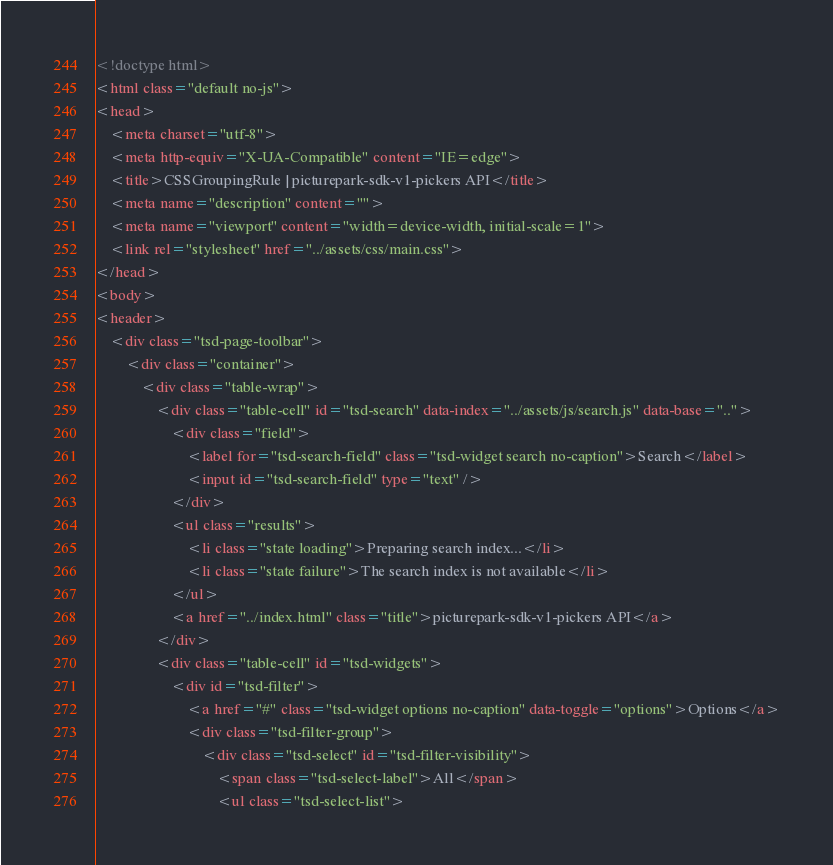<code> <loc_0><loc_0><loc_500><loc_500><_HTML_><!doctype html>
<html class="default no-js">
<head>
	<meta charset="utf-8">
	<meta http-equiv="X-UA-Compatible" content="IE=edge">
	<title>CSSGroupingRule | picturepark-sdk-v1-pickers API</title>
	<meta name="description" content="">
	<meta name="viewport" content="width=device-width, initial-scale=1">
	<link rel="stylesheet" href="../assets/css/main.css">
</head>
<body>
<header>
	<div class="tsd-page-toolbar">
		<div class="container">
			<div class="table-wrap">
				<div class="table-cell" id="tsd-search" data-index="../assets/js/search.js" data-base="..">
					<div class="field">
						<label for="tsd-search-field" class="tsd-widget search no-caption">Search</label>
						<input id="tsd-search-field" type="text" />
					</div>
					<ul class="results">
						<li class="state loading">Preparing search index...</li>
						<li class="state failure">The search index is not available</li>
					</ul>
					<a href="../index.html" class="title">picturepark-sdk-v1-pickers API</a>
				</div>
				<div class="table-cell" id="tsd-widgets">
					<div id="tsd-filter">
						<a href="#" class="tsd-widget options no-caption" data-toggle="options">Options</a>
						<div class="tsd-filter-group">
							<div class="tsd-select" id="tsd-filter-visibility">
								<span class="tsd-select-label">All</span>
								<ul class="tsd-select-list"></code> 